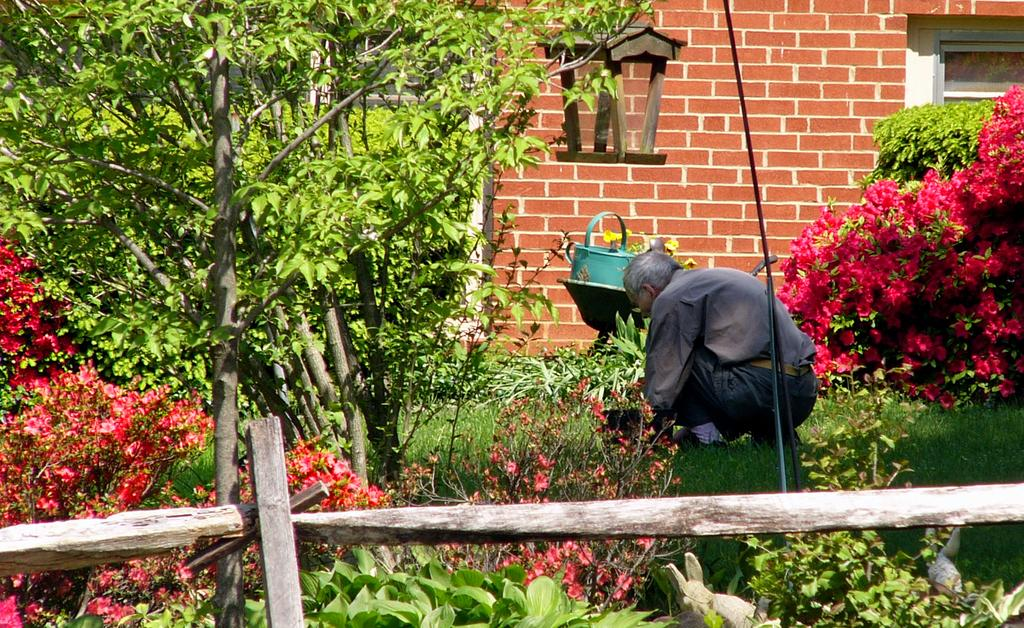What types of vegetation can be seen in the foreground of the image? There are plants and trees in the foreground of the image. What other objects can be seen in the foreground of the image? There is a railing, flowers, a man on the grass, a lamp, and a wall in the foreground of the image. Can you provide an example of a doctor in the image? There is no doctor present in the image. Is there a stream visible in the image? There is no stream present in the image. 